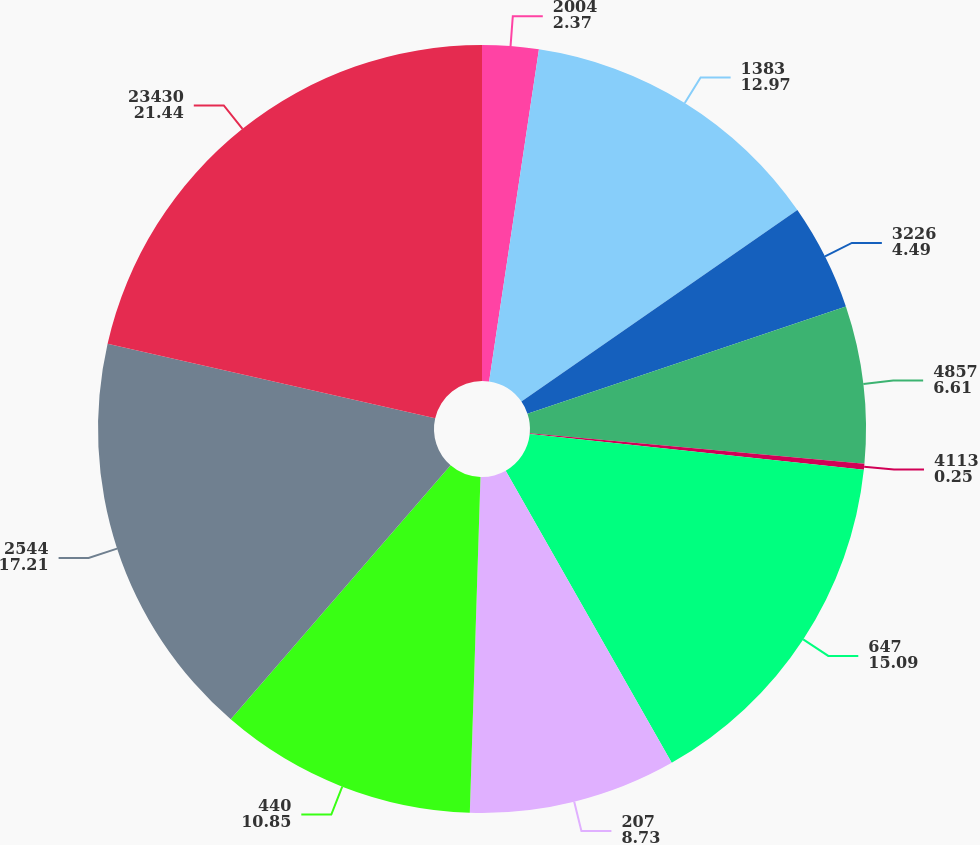Convert chart to OTSL. <chart><loc_0><loc_0><loc_500><loc_500><pie_chart><fcel>2004<fcel>1383<fcel>3226<fcel>4857<fcel>4113<fcel>647<fcel>207<fcel>440<fcel>2544<fcel>23430<nl><fcel>2.37%<fcel>12.97%<fcel>4.49%<fcel>6.61%<fcel>0.25%<fcel>15.09%<fcel>8.73%<fcel>10.85%<fcel>17.21%<fcel>21.44%<nl></chart> 